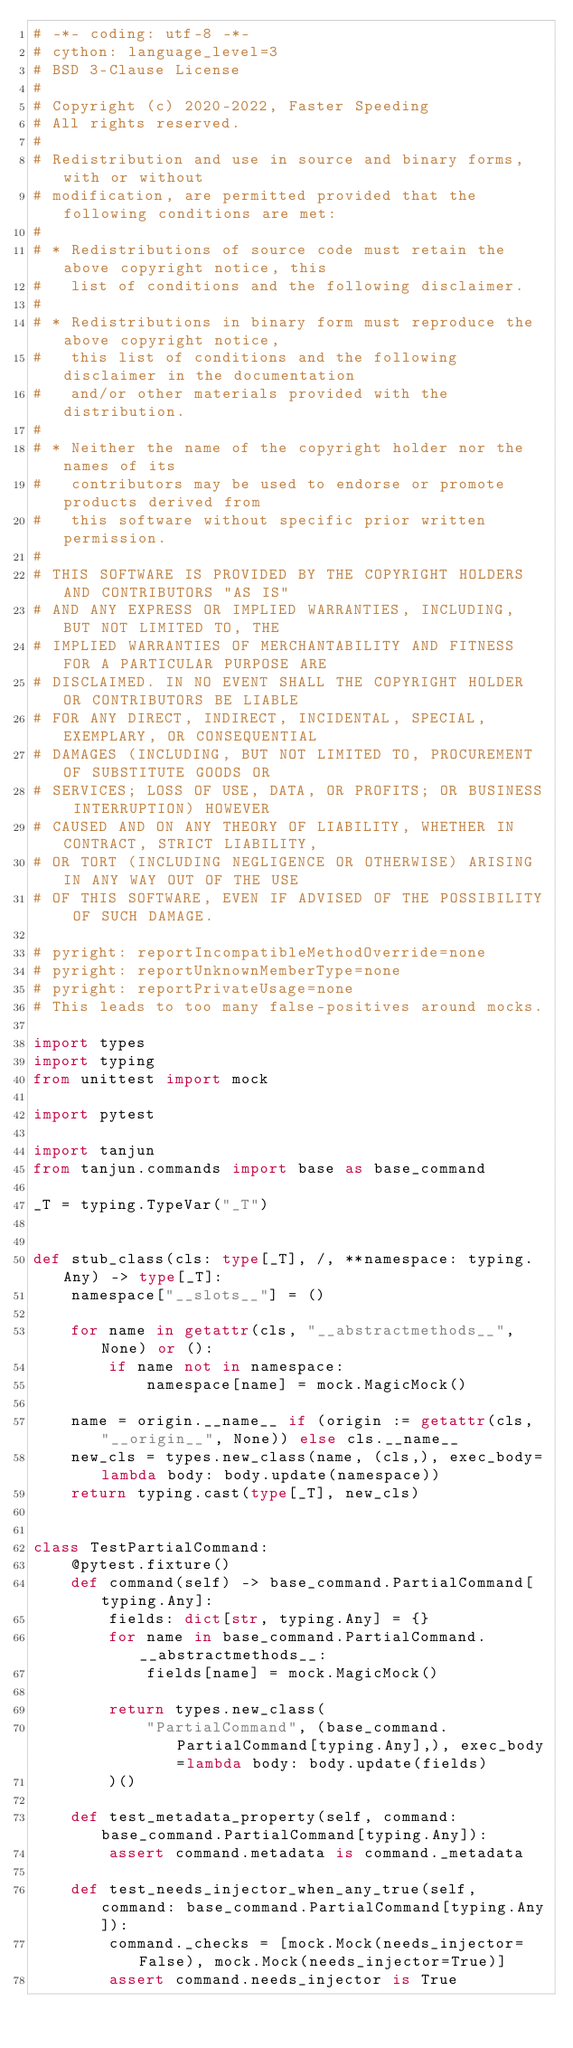<code> <loc_0><loc_0><loc_500><loc_500><_Python_># -*- coding: utf-8 -*-
# cython: language_level=3
# BSD 3-Clause License
#
# Copyright (c) 2020-2022, Faster Speeding
# All rights reserved.
#
# Redistribution and use in source and binary forms, with or without
# modification, are permitted provided that the following conditions are met:
#
# * Redistributions of source code must retain the above copyright notice, this
#   list of conditions and the following disclaimer.
#
# * Redistributions in binary form must reproduce the above copyright notice,
#   this list of conditions and the following disclaimer in the documentation
#   and/or other materials provided with the distribution.
#
# * Neither the name of the copyright holder nor the names of its
#   contributors may be used to endorse or promote products derived from
#   this software without specific prior written permission.
#
# THIS SOFTWARE IS PROVIDED BY THE COPYRIGHT HOLDERS AND CONTRIBUTORS "AS IS"
# AND ANY EXPRESS OR IMPLIED WARRANTIES, INCLUDING, BUT NOT LIMITED TO, THE
# IMPLIED WARRANTIES OF MERCHANTABILITY AND FITNESS FOR A PARTICULAR PURPOSE ARE
# DISCLAIMED. IN NO EVENT SHALL THE COPYRIGHT HOLDER OR CONTRIBUTORS BE LIABLE
# FOR ANY DIRECT, INDIRECT, INCIDENTAL, SPECIAL, EXEMPLARY, OR CONSEQUENTIAL
# DAMAGES (INCLUDING, BUT NOT LIMITED TO, PROCUREMENT OF SUBSTITUTE GOODS OR
# SERVICES; LOSS OF USE, DATA, OR PROFITS; OR BUSINESS INTERRUPTION) HOWEVER
# CAUSED AND ON ANY THEORY OF LIABILITY, WHETHER IN CONTRACT, STRICT LIABILITY,
# OR TORT (INCLUDING NEGLIGENCE OR OTHERWISE) ARISING IN ANY WAY OUT OF THE USE
# OF THIS SOFTWARE, EVEN IF ADVISED OF THE POSSIBILITY OF SUCH DAMAGE.

# pyright: reportIncompatibleMethodOverride=none
# pyright: reportUnknownMemberType=none
# pyright: reportPrivateUsage=none
# This leads to too many false-positives around mocks.

import types
import typing
from unittest import mock

import pytest

import tanjun
from tanjun.commands import base as base_command

_T = typing.TypeVar("_T")


def stub_class(cls: type[_T], /, **namespace: typing.Any) -> type[_T]:
    namespace["__slots__"] = ()

    for name in getattr(cls, "__abstractmethods__", None) or ():
        if name not in namespace:
            namespace[name] = mock.MagicMock()

    name = origin.__name__ if (origin := getattr(cls, "__origin__", None)) else cls.__name__
    new_cls = types.new_class(name, (cls,), exec_body=lambda body: body.update(namespace))
    return typing.cast(type[_T], new_cls)


class TestPartialCommand:
    @pytest.fixture()
    def command(self) -> base_command.PartialCommand[typing.Any]:
        fields: dict[str, typing.Any] = {}
        for name in base_command.PartialCommand.__abstractmethods__:
            fields[name] = mock.MagicMock()

        return types.new_class(
            "PartialCommand", (base_command.PartialCommand[typing.Any],), exec_body=lambda body: body.update(fields)
        )()

    def test_metadata_property(self, command: base_command.PartialCommand[typing.Any]):
        assert command.metadata is command._metadata

    def test_needs_injector_when_any_true(self, command: base_command.PartialCommand[typing.Any]):
        command._checks = [mock.Mock(needs_injector=False), mock.Mock(needs_injector=True)]
        assert command.needs_injector is True
</code> 